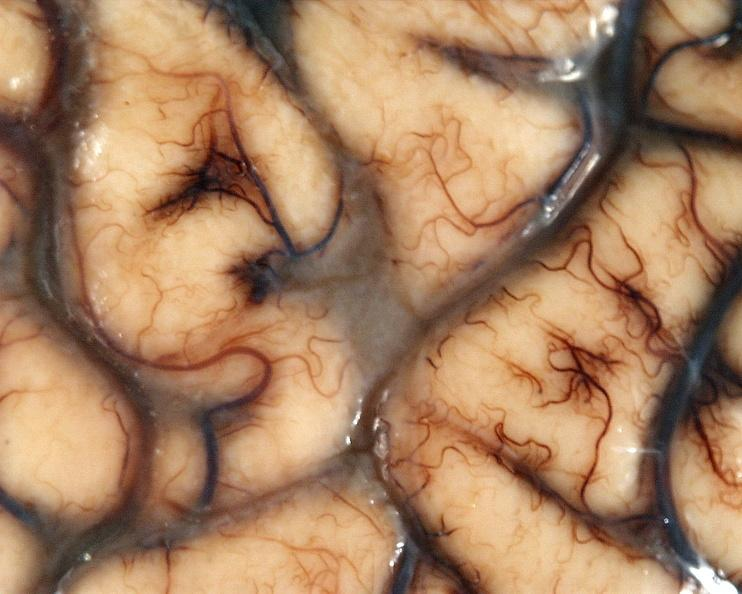what is present?
Answer the question using a single word or phrase. Nervous 